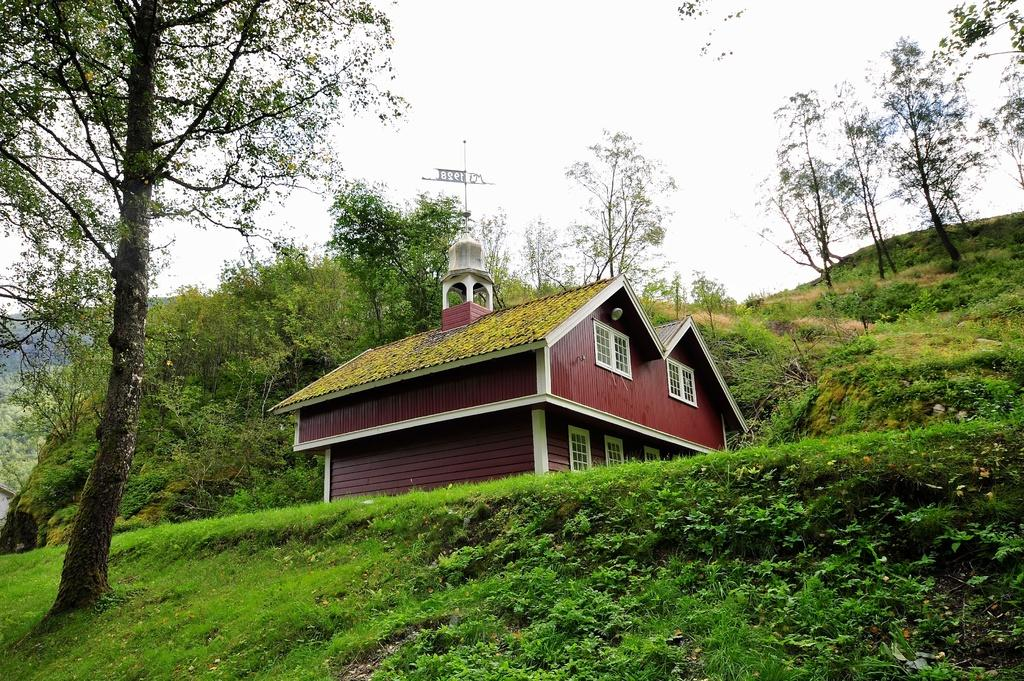What type of vegetation is in the foreground of the image? There is grass and plants in the foreground of the image. What can be seen on the left side of the image? There is a tree on the left side of the image. What structure is located in the middle of the image? There is a house in the middle of the image. What is visible behind the house? There are trees behind the house. What is visible at the top of the image? The sky is visible at the top of the image. Where is the shop selling wine located in the image? There is no shop or wine present in the image. Is there a bridge visible in the image? No, there is no bridge visible in the image. 